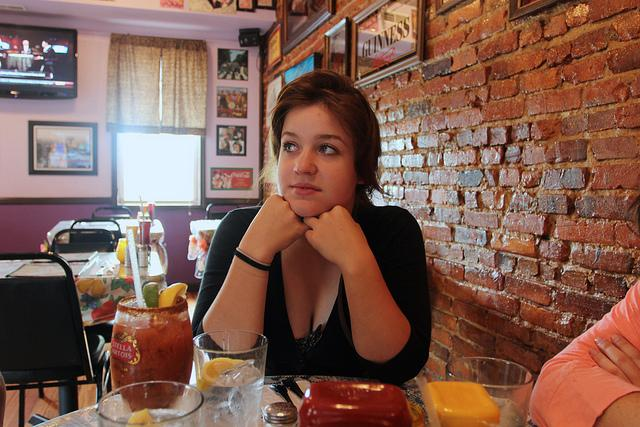What is held in the red and yellow containers on the table?

Choices:
A) lettuce
B) eggs
C) condiments
D) salad dressing condiments 